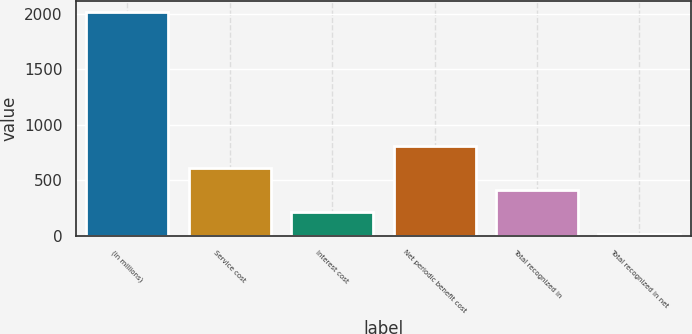<chart> <loc_0><loc_0><loc_500><loc_500><bar_chart><fcel>(in millions)<fcel>Service cost<fcel>Interest cost<fcel>Net periodic benefit cost<fcel>Total recognized in<fcel>Total recognized in net<nl><fcel>2015<fcel>612.9<fcel>212.3<fcel>813.2<fcel>412.6<fcel>12<nl></chart> 